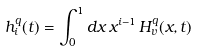<formula> <loc_0><loc_0><loc_500><loc_500>h ^ { q } _ { i } ( t ) = \int _ { 0 } ^ { 1 } d x \, x ^ { i - 1 } \, H _ { v } ^ { q } ( x , t )</formula> 